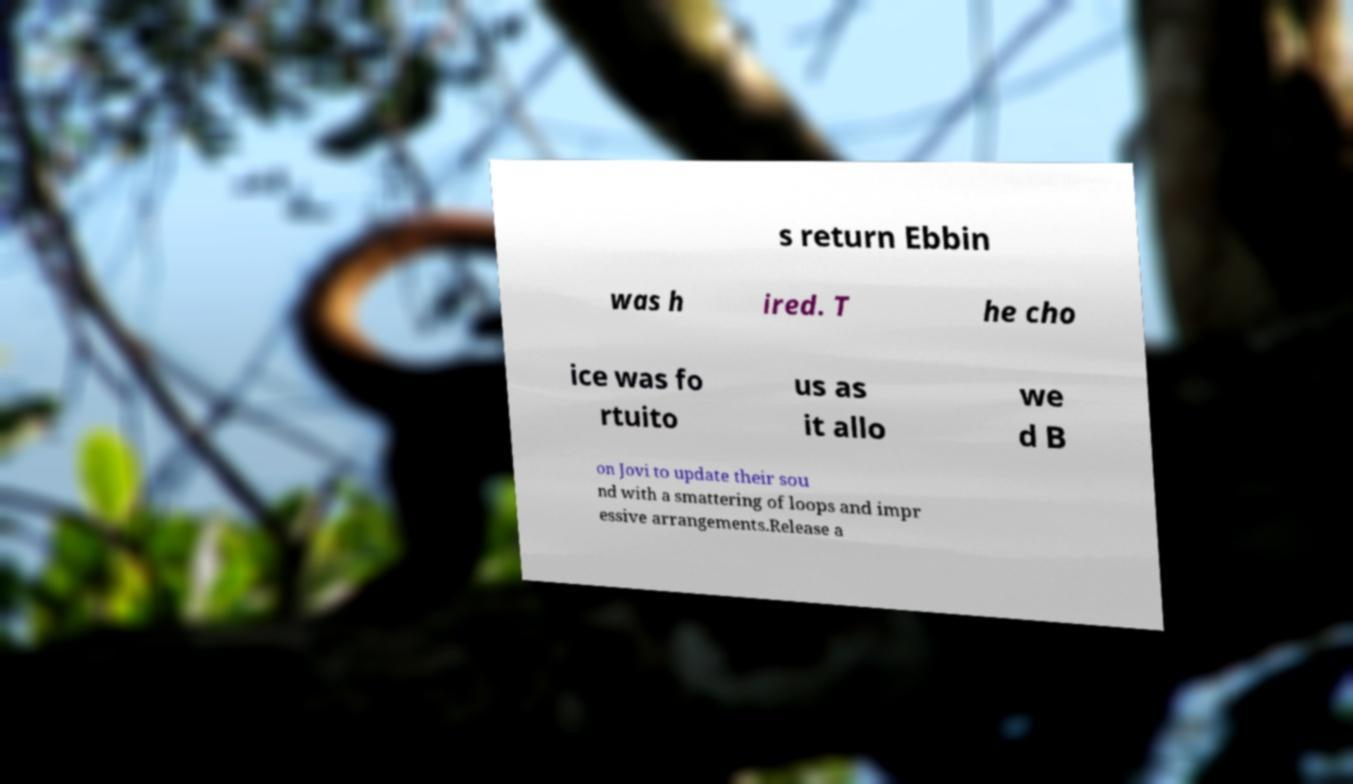Could you extract and type out the text from this image? s return Ebbin was h ired. T he cho ice was fo rtuito us as it allo we d B on Jovi to update their sou nd with a smattering of loops and impr essive arrangements.Release a 